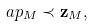Convert formula to latex. <formula><loc_0><loc_0><loc_500><loc_500>\ a p _ { M } \prec { \mathbf z _ { M } } ,</formula> 